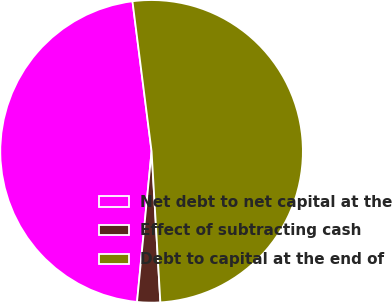Convert chart. <chart><loc_0><loc_0><loc_500><loc_500><pie_chart><fcel>Net debt to net capital at the<fcel>Effect of subtracting cash<fcel>Debt to capital at the end of<nl><fcel>46.45%<fcel>2.46%<fcel>51.09%<nl></chart> 